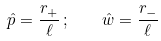<formula> <loc_0><loc_0><loc_500><loc_500>\hat { p } = \frac { r _ { + } } { \ell } \, ; \quad \hat { w } = \frac { r _ { - } } { \ell }</formula> 